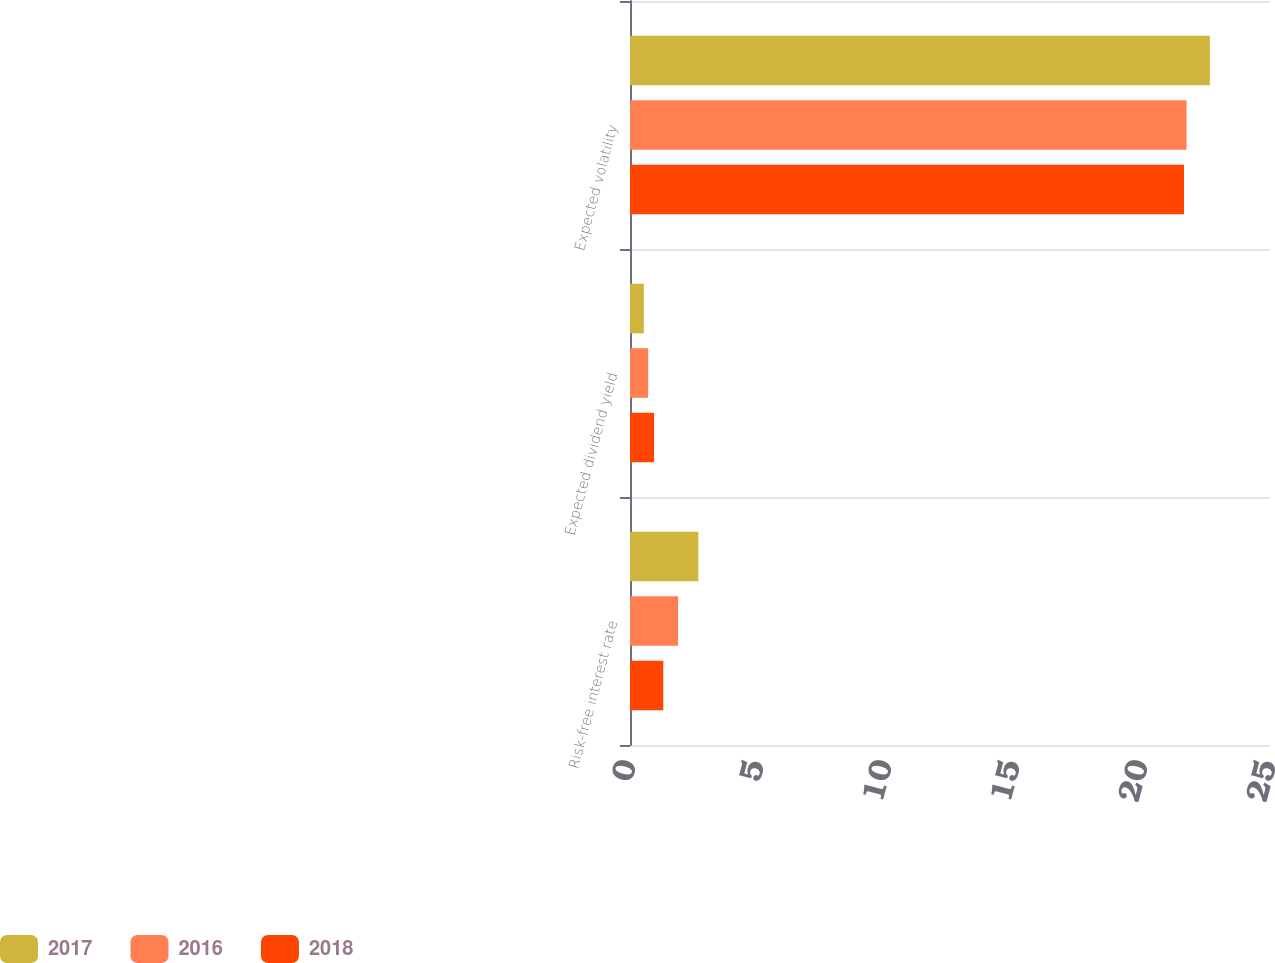Convert chart to OTSL. <chart><loc_0><loc_0><loc_500><loc_500><stacked_bar_chart><ecel><fcel>Risk-free interest rate<fcel>Expected dividend yield<fcel>Expected volatility<nl><fcel>2017<fcel>2.67<fcel>0.54<fcel>22.65<nl><fcel>2016<fcel>1.88<fcel>0.71<fcel>21.74<nl><fcel>2018<fcel>1.3<fcel>0.94<fcel>21.64<nl></chart> 